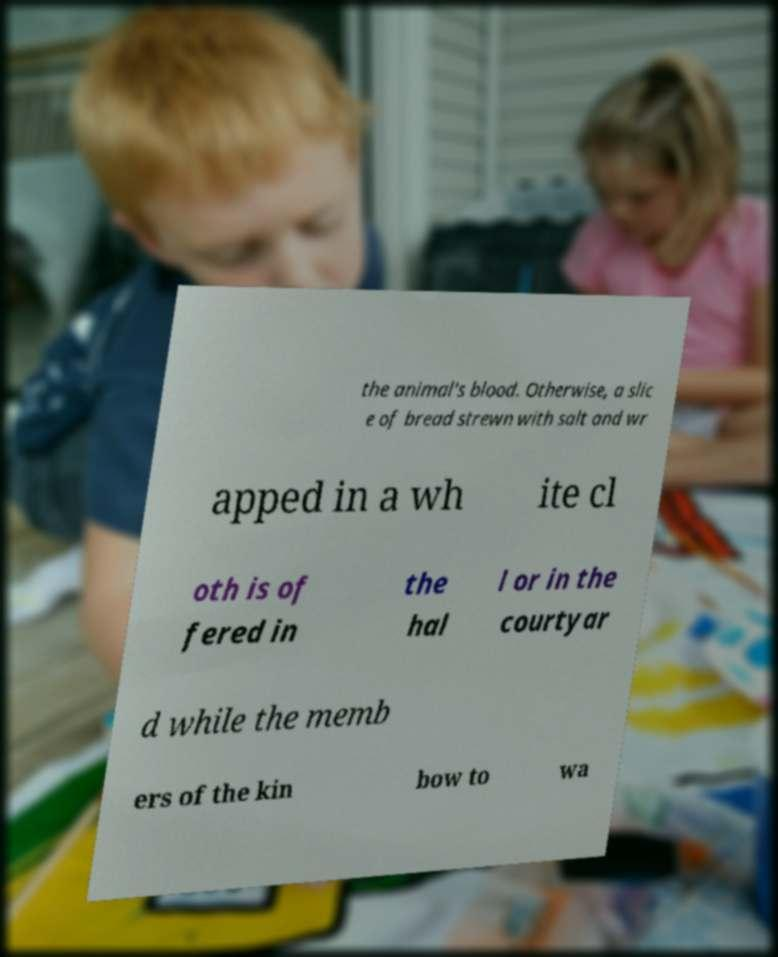I need the written content from this picture converted into text. Can you do that? the animal's blood. Otherwise, a slic e of bread strewn with salt and wr apped in a wh ite cl oth is of fered in the hal l or in the courtyar d while the memb ers of the kin bow to wa 